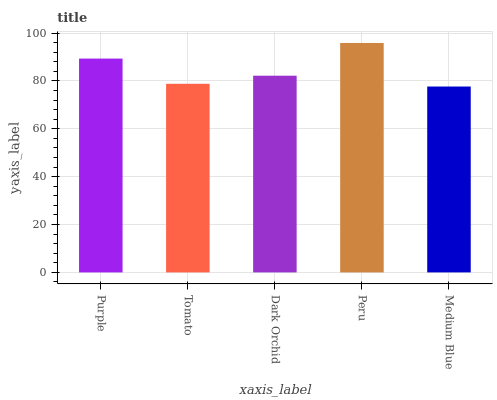Is Medium Blue the minimum?
Answer yes or no. Yes. Is Peru the maximum?
Answer yes or no. Yes. Is Tomato the minimum?
Answer yes or no. No. Is Tomato the maximum?
Answer yes or no. No. Is Purple greater than Tomato?
Answer yes or no. Yes. Is Tomato less than Purple?
Answer yes or no. Yes. Is Tomato greater than Purple?
Answer yes or no. No. Is Purple less than Tomato?
Answer yes or no. No. Is Dark Orchid the high median?
Answer yes or no. Yes. Is Dark Orchid the low median?
Answer yes or no. Yes. Is Purple the high median?
Answer yes or no. No. Is Tomato the low median?
Answer yes or no. No. 